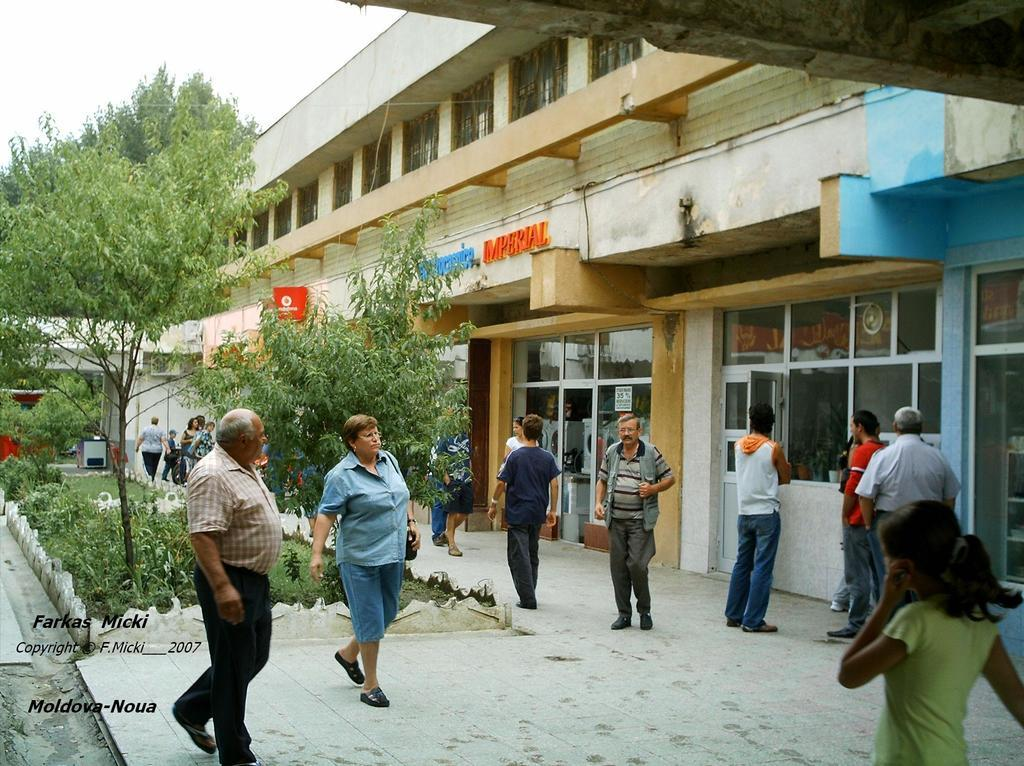What type of natural elements can be seen in the image? There are trees in the image. Can you describe the people in the image? There is a group of people in the image. What can be seen in the distance in the image? There are buildings in the background of the image. Where is the text located in the image? The text is in the bottom left hand corner of the image. How many dolls are sitting on the cap in the image? There are no dolls or caps present in the image. What type of verse can be seen written on the trees in the image? There is no verse written on the trees in the image; only the trees themselves are visible. 